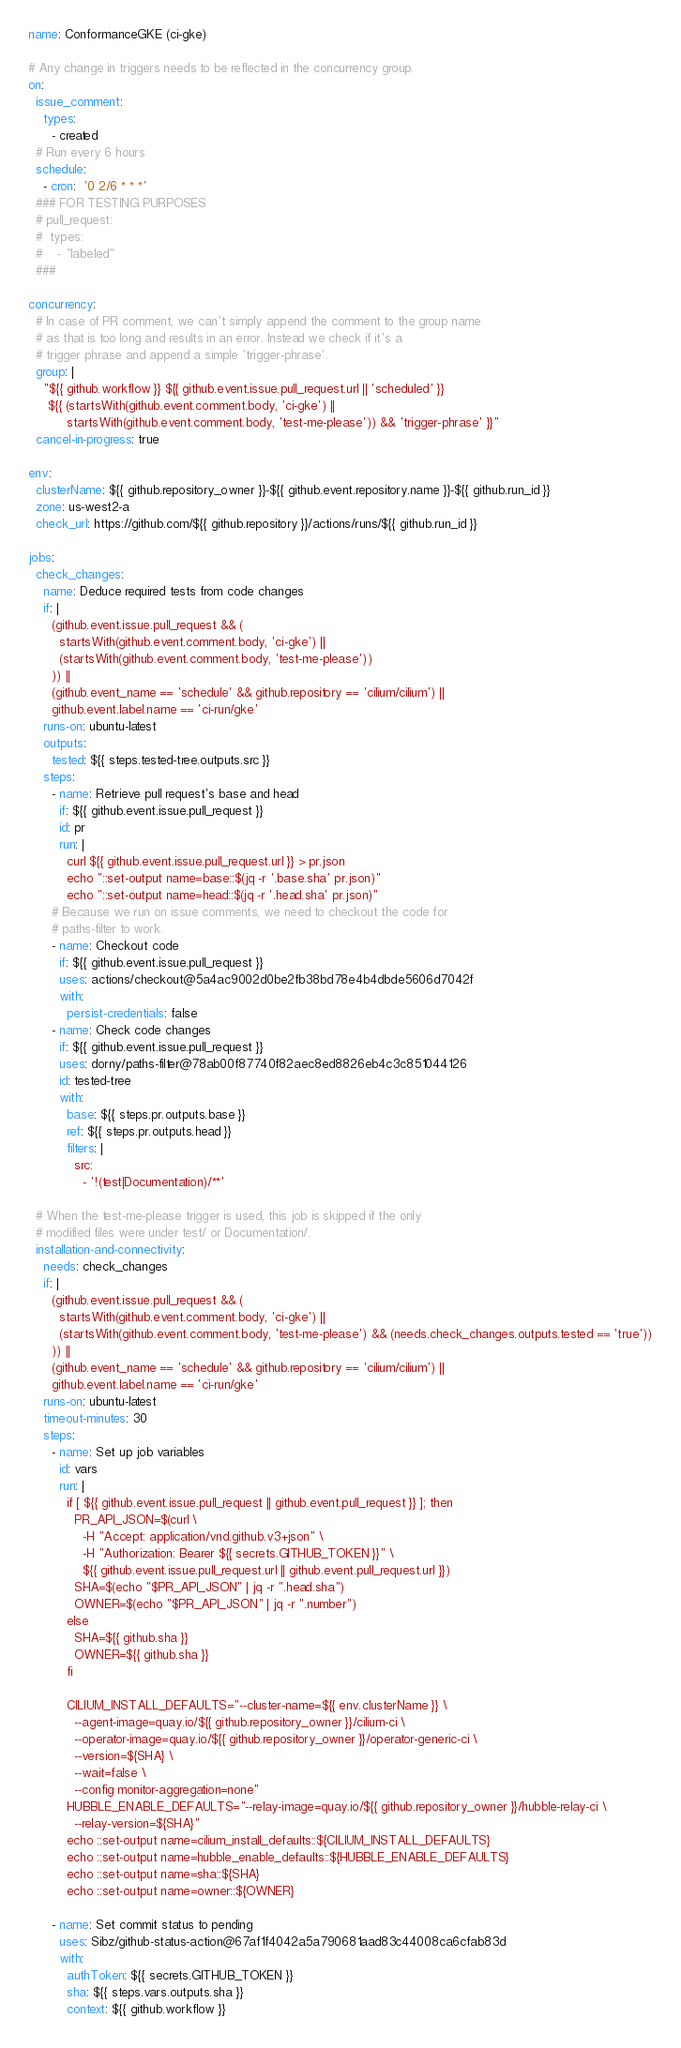Convert code to text. <code><loc_0><loc_0><loc_500><loc_500><_YAML_>name: ConformanceGKE (ci-gke)

# Any change in triggers needs to be reflected in the concurrency group.
on:
  issue_comment:
    types:
      - created
  # Run every 6 hours
  schedule:
    - cron:  '0 2/6 * * *'
  ### FOR TESTING PURPOSES
  # pull_request:
  #  types:
  #    - "labeled"
  ###

concurrency:
  # In case of PR comment, we can't simply append the comment to the group name
  # as that is too long and results in an error. Instead we check if it's a
  # trigger phrase and append a simple 'trigger-phrase'.
  group: |
    "${{ github.workflow }} ${{ github.event.issue.pull_request.url || 'scheduled' }}
     ${{ (startsWith(github.event.comment.body, 'ci-gke') ||
          startsWith(github.event.comment.body, 'test-me-please')) && 'trigger-phrase' }}"
  cancel-in-progress: true

env:
  clusterName: ${{ github.repository_owner }}-${{ github.event.repository.name }}-${{ github.run_id }}
  zone: us-west2-a
  check_url: https://github.com/${{ github.repository }}/actions/runs/${{ github.run_id }}

jobs:
  check_changes:
    name: Deduce required tests from code changes
    if: |
      (github.event.issue.pull_request && (
        startsWith(github.event.comment.body, 'ci-gke') ||
        (startsWith(github.event.comment.body, 'test-me-please'))
      )) ||
      (github.event_name == 'schedule' && github.repository == 'cilium/cilium') ||
      github.event.label.name == 'ci-run/gke'
    runs-on: ubuntu-latest
    outputs:
      tested: ${{ steps.tested-tree.outputs.src }}
    steps:
      - name: Retrieve pull request's base and head
        if: ${{ github.event.issue.pull_request }}
        id: pr
        run: |
          curl ${{ github.event.issue.pull_request.url }} > pr.json
          echo "::set-output name=base::$(jq -r '.base.sha' pr.json)"
          echo "::set-output name=head::$(jq -r '.head.sha' pr.json)"
      # Because we run on issue comments, we need to checkout the code for
      # paths-filter to work.
      - name: Checkout code
        if: ${{ github.event.issue.pull_request }}
        uses: actions/checkout@5a4ac9002d0be2fb38bd78e4b4dbde5606d7042f
        with:
          persist-credentials: false
      - name: Check code changes
        if: ${{ github.event.issue.pull_request }}
        uses: dorny/paths-filter@78ab00f87740f82aec8ed8826eb4c3c851044126
        id: tested-tree
        with:
          base: ${{ steps.pr.outputs.base }}
          ref: ${{ steps.pr.outputs.head }}
          filters: |
            src:
              - '!(test|Documentation)/**'

  # When the test-me-please trigger is used, this job is skipped if the only
  # modified files were under test/ or Documentation/.
  installation-and-connectivity:
    needs: check_changes
    if: |
      (github.event.issue.pull_request && (
        startsWith(github.event.comment.body, 'ci-gke') ||
        (startsWith(github.event.comment.body, 'test-me-please') && (needs.check_changes.outputs.tested == 'true'))
      )) ||
      (github.event_name == 'schedule' && github.repository == 'cilium/cilium') ||
      github.event.label.name == 'ci-run/gke'
    runs-on: ubuntu-latest
    timeout-minutes: 30
    steps:
      - name: Set up job variables
        id: vars
        run: |
          if [ ${{ github.event.issue.pull_request || github.event.pull_request }} ]; then
            PR_API_JSON=$(curl \
              -H "Accept: application/vnd.github.v3+json" \
              -H "Authorization: Bearer ${{ secrets.GITHUB_TOKEN }}" \
              ${{ github.event.issue.pull_request.url || github.event.pull_request.url }})
            SHA=$(echo "$PR_API_JSON" | jq -r ".head.sha")
            OWNER=$(echo "$PR_API_JSON" | jq -r ".number")
          else
            SHA=${{ github.sha }}
            OWNER=${{ github.sha }}
          fi

          CILIUM_INSTALL_DEFAULTS="--cluster-name=${{ env.clusterName }} \
            --agent-image=quay.io/${{ github.repository_owner }}/cilium-ci \
            --operator-image=quay.io/${{ github.repository_owner }}/operator-generic-ci \
            --version=${SHA} \
            --wait=false \
            --config monitor-aggregation=none"
          HUBBLE_ENABLE_DEFAULTS="--relay-image=quay.io/${{ github.repository_owner }}/hubble-relay-ci \
            --relay-version=${SHA}"
          echo ::set-output name=cilium_install_defaults::${CILIUM_INSTALL_DEFAULTS}
          echo ::set-output name=hubble_enable_defaults::${HUBBLE_ENABLE_DEFAULTS}
          echo ::set-output name=sha::${SHA}
          echo ::set-output name=owner::${OWNER}

      - name: Set commit status to pending
        uses: Sibz/github-status-action@67af1f4042a5a790681aad83c44008ca6cfab83d
        with:
          authToken: ${{ secrets.GITHUB_TOKEN }}
          sha: ${{ steps.vars.outputs.sha }}
          context: ${{ github.workflow }}</code> 